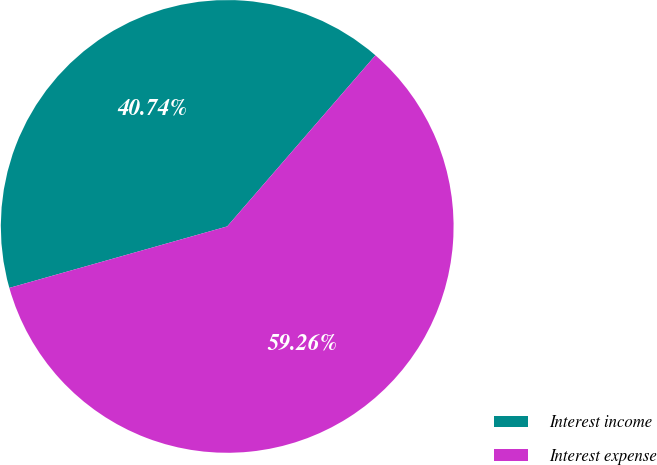<chart> <loc_0><loc_0><loc_500><loc_500><pie_chart><fcel>Interest income<fcel>Interest expense<nl><fcel>40.74%<fcel>59.26%<nl></chart> 